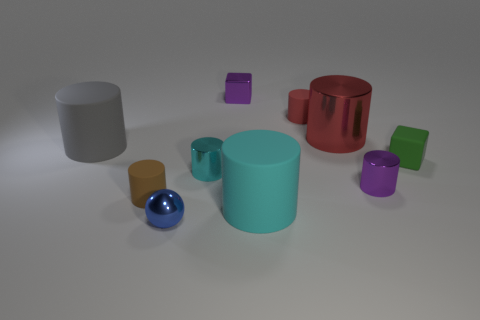Subtract 5 cylinders. How many cylinders are left? 2 Subtract all purple cylinders. How many cylinders are left? 6 Subtract all brown cylinders. How many cylinders are left? 6 Subtract all yellow cylinders. Subtract all cyan cubes. How many cylinders are left? 7 Subtract all cubes. How many objects are left? 8 Add 5 tiny red cylinders. How many tiny red cylinders exist? 6 Subtract 0 yellow cylinders. How many objects are left? 10 Subtract all purple metal objects. Subtract all small yellow metal balls. How many objects are left? 8 Add 3 matte cylinders. How many matte cylinders are left? 7 